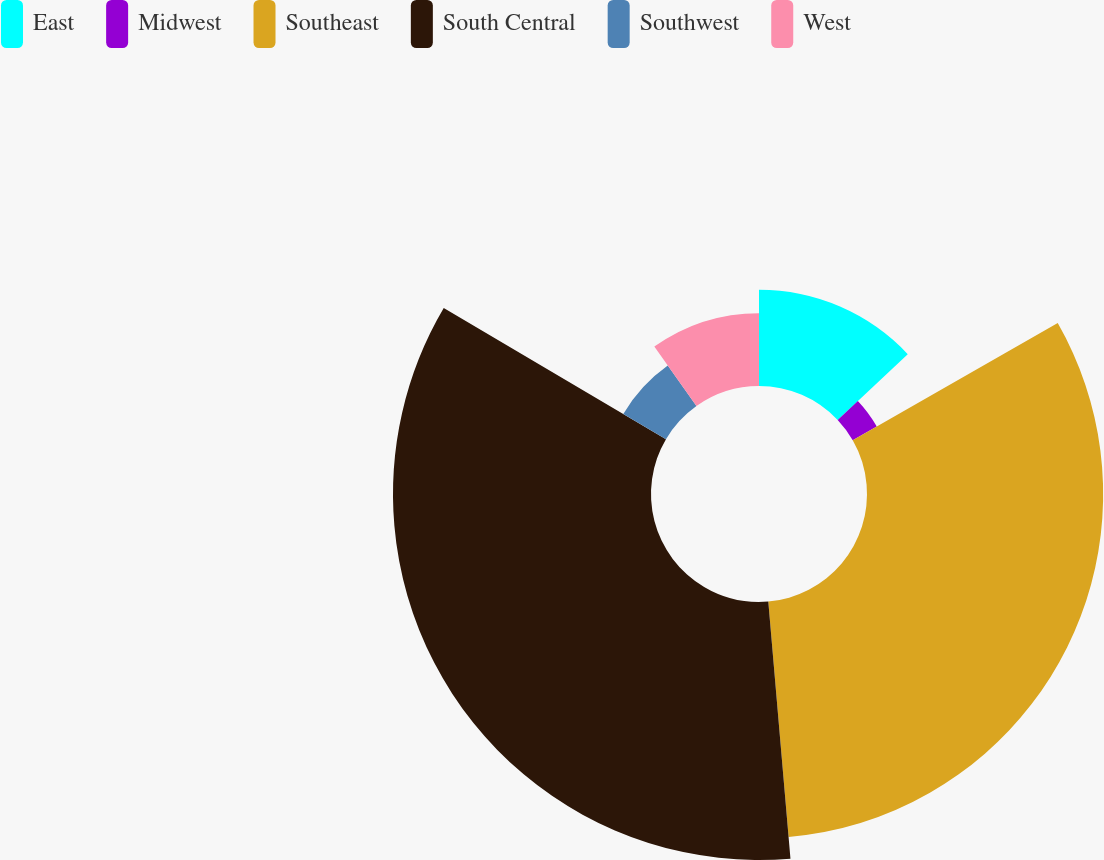Convert chart. <chart><loc_0><loc_0><loc_500><loc_500><pie_chart><fcel>East<fcel>Midwest<fcel>Southeast<fcel>South Central<fcel>Southwest<fcel>West<nl><fcel>12.99%<fcel>3.74%<fcel>31.9%<fcel>34.85%<fcel>6.69%<fcel>9.83%<nl></chart> 